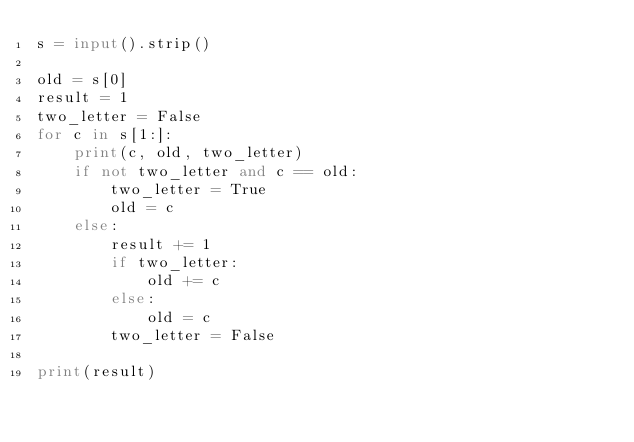<code> <loc_0><loc_0><loc_500><loc_500><_Python_>s = input().strip()

old = s[0]
result = 1
two_letter = False
for c in s[1:]:
    print(c, old, two_letter)
    if not two_letter and c == old:
        two_letter = True
        old = c
    else:
        result += 1
        if two_letter:
            old += c
        else:
            old = c
        two_letter = False

print(result)
</code> 